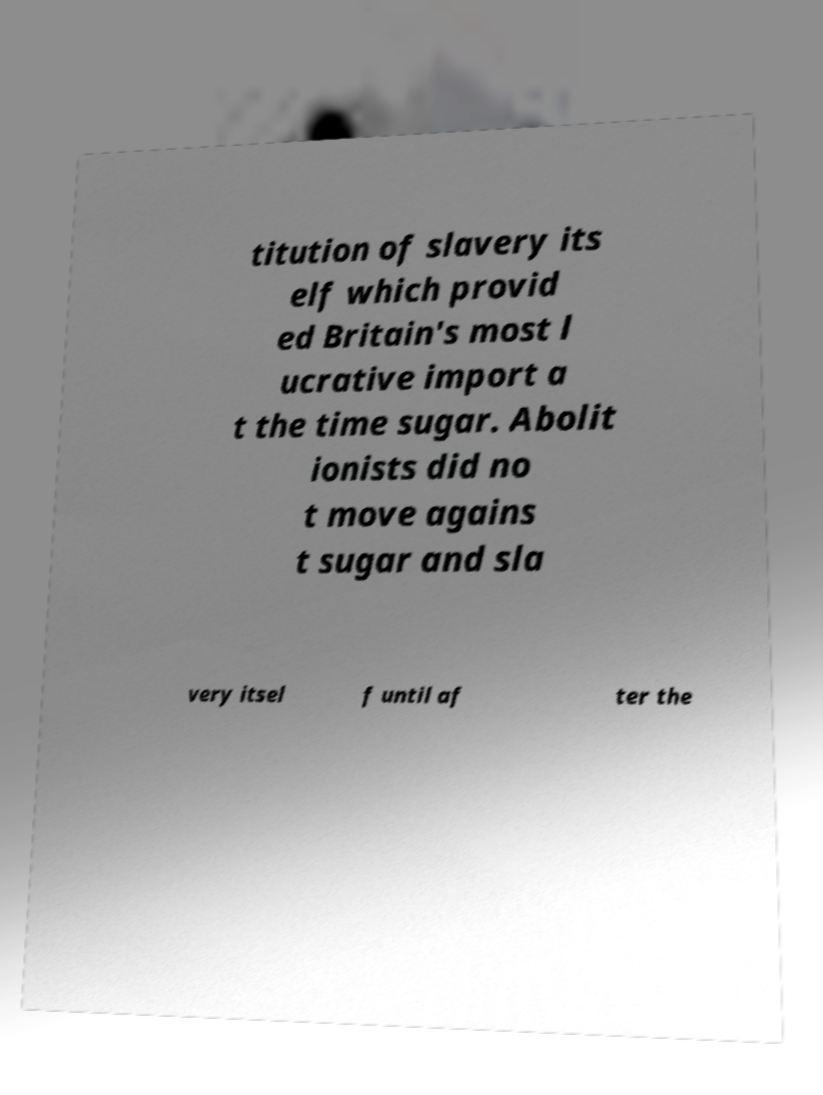Could you assist in decoding the text presented in this image and type it out clearly? titution of slavery its elf which provid ed Britain's most l ucrative import a t the time sugar. Abolit ionists did no t move agains t sugar and sla very itsel f until af ter the 